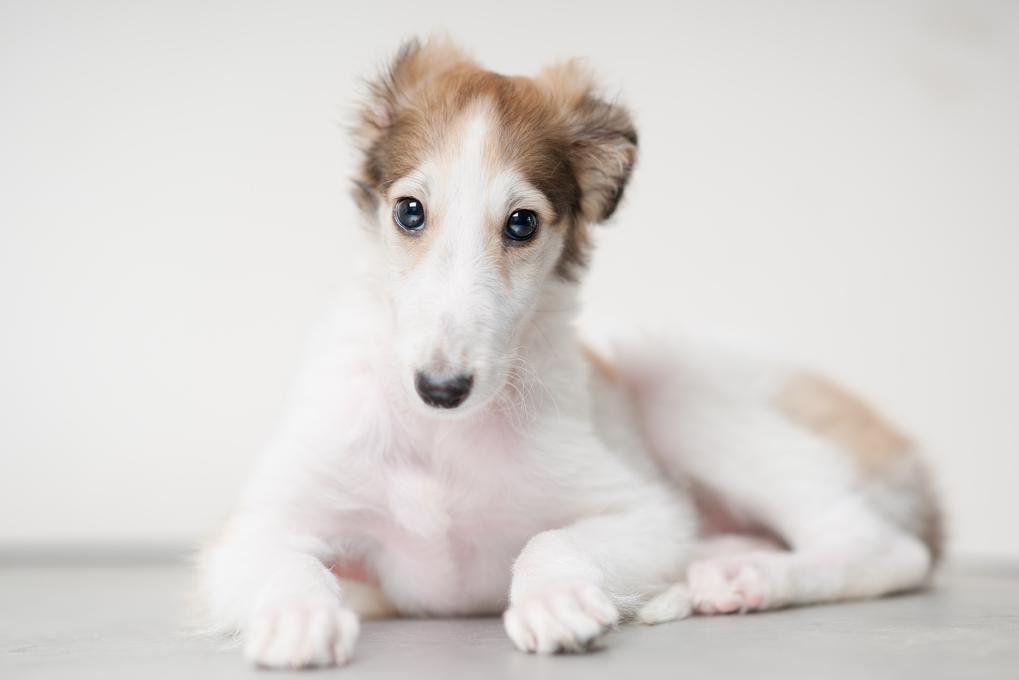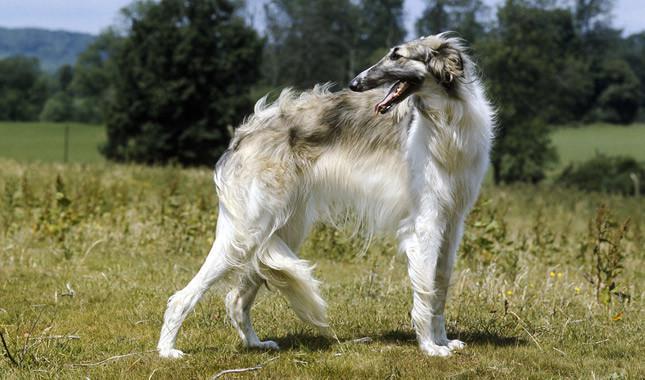The first image is the image on the left, the second image is the image on the right. Evaluate the accuracy of this statement regarding the images: "A person is training a long haired dog.". Is it true? Answer yes or no. No. The first image is the image on the left, the second image is the image on the right. For the images displayed, is the sentence "In at least one image there is a woman whose body is facing left  while showing a tall dog with some white fur." factually correct? Answer yes or no. No. 